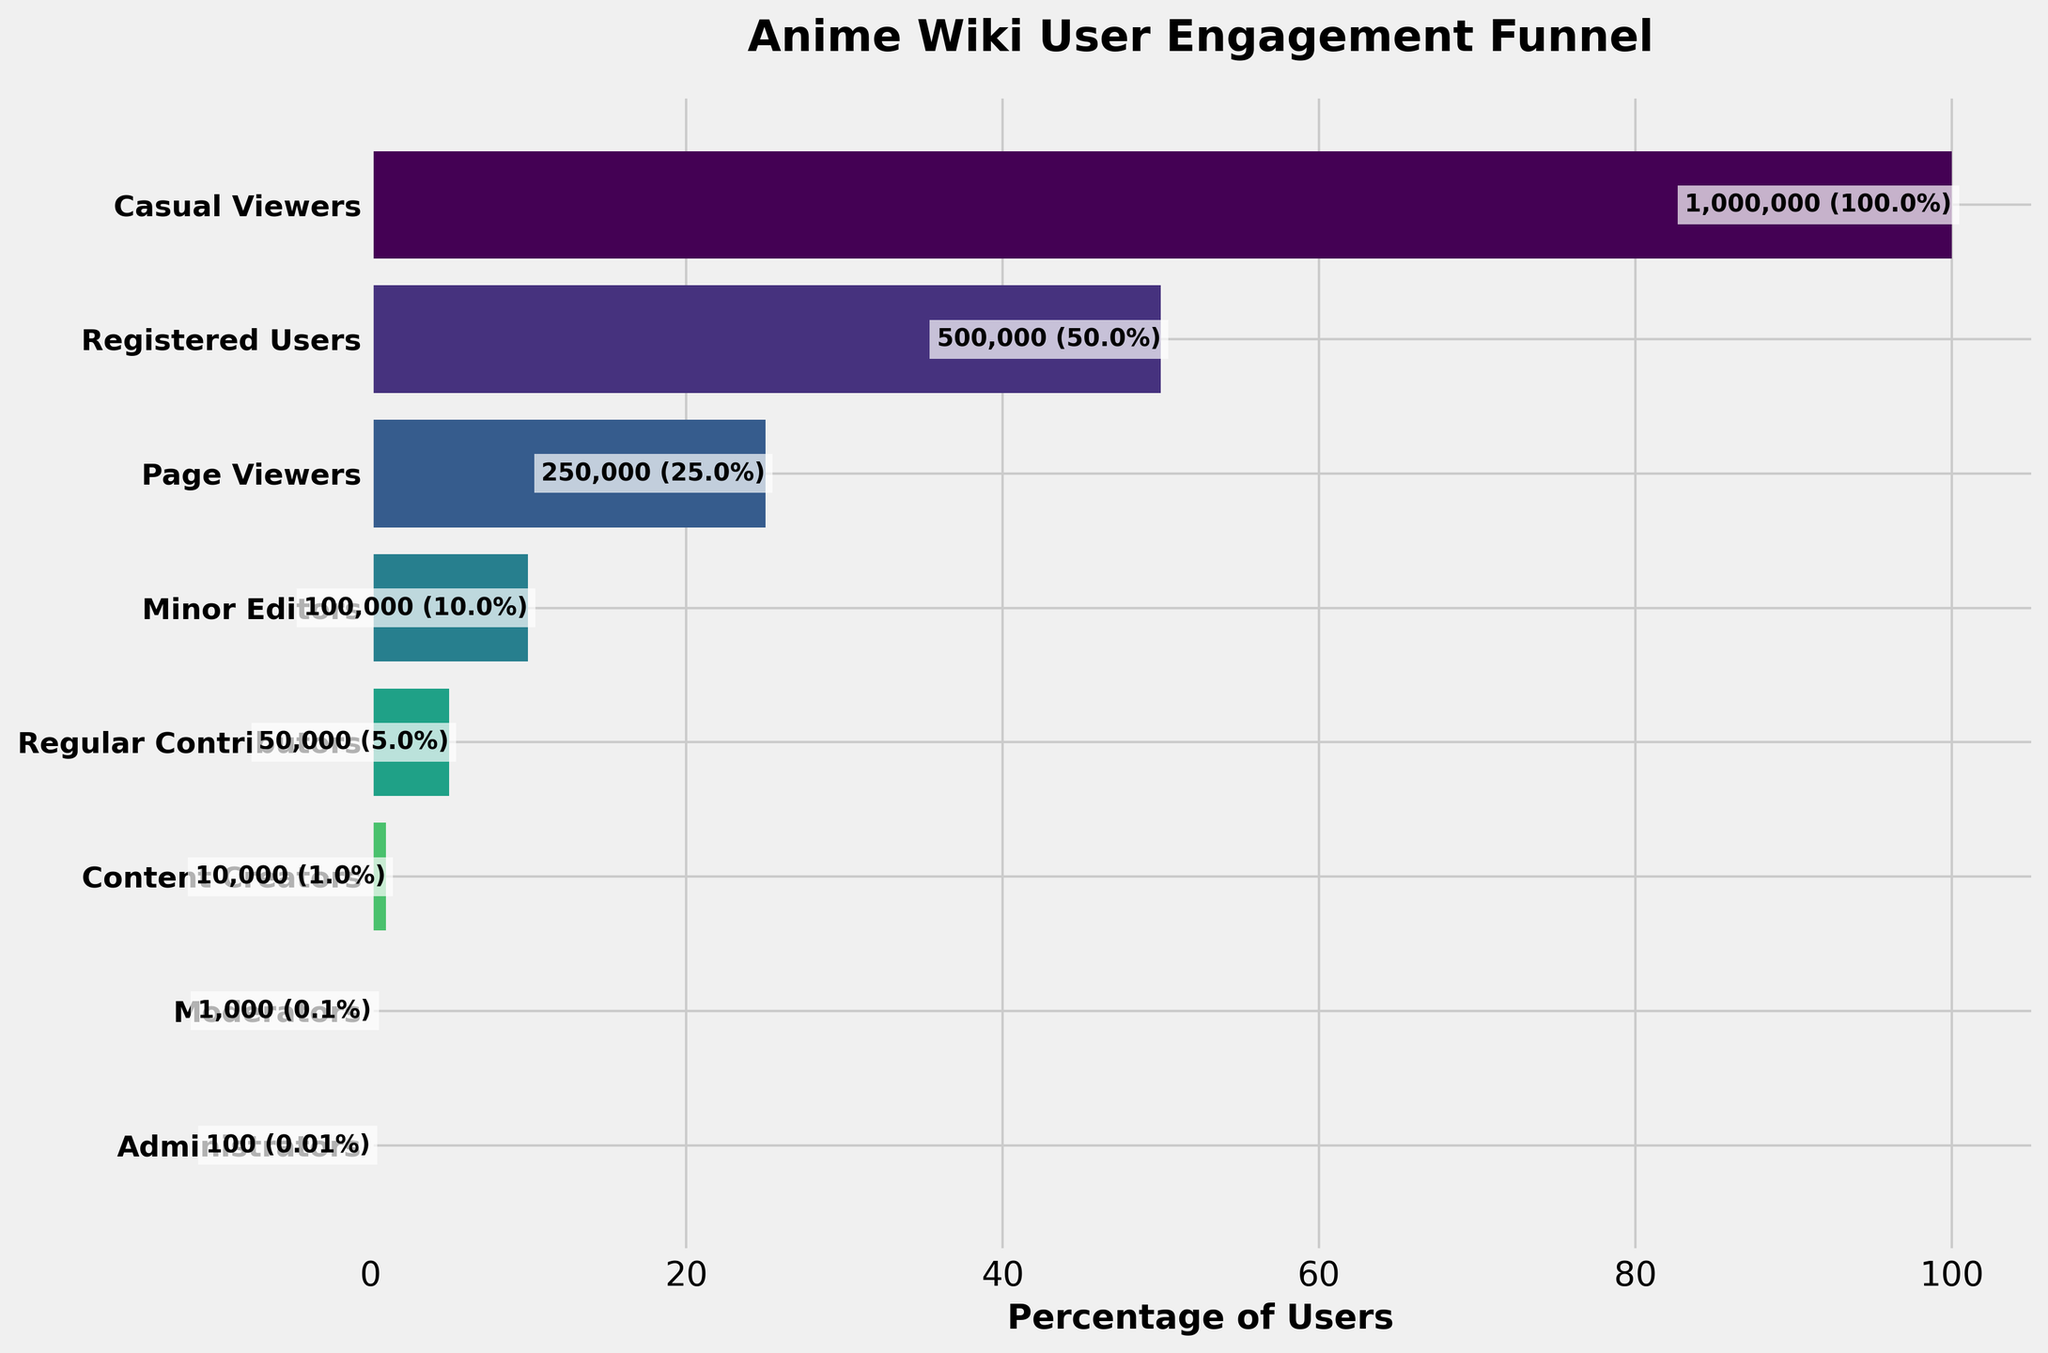What is the title of the figure? The title is located at the top of the funnel chart, it is clearly labeled to explain the main subject of the chart.
Answer: Anime Wiki User Engagement Funnel Which stage has the highest number of users? The longest bar in the funnel chart represents the stage with the highest number of users. It is the top-most level, which is "Casual Viewers".
Answer: Casual Viewers How many users are marked as "Moderators"? Look for the bar labeled "Moderators" and read the number of users next to it. The value provided is 1,000 users.
Answer: 1,000 Compare the number of "Minor Editors" to "Content Creators". Which group has more users and by how many? The bar for "Minor Editors" indicates 100,000 users and the bar for "Content Creators" indicates 10,000 users. By subtracting these, we find that Minor Editors have 90,000 more users.
Answer: Minor Editors have 90,000 more users What percentage of users are "Registered Users"? The percentage for each stage is displayed at the end of each bar. For "Registered Users", it shows 50%.
Answer: 50% What is the total number of users represented in the funnel chart? The total number of users can be directly inferred from the top-most bar labeled "Casual Viewers", which represents the initial total population of users. This value is 1,000,000 users.
Answer: 1,000,000 Which stage shows the greatest drop in user numbers compared to the previous stage? Compare the drop in user numbers between each consecutive stage. The largest drop is from "Regular Contributors" (50,000 users) to "Content Creators" (10,000 users), resulting in a decrease of 40,000 users.
Answer: From Regular Contributors to Content Creators What is the percentage difference between "Regular Contributors" and "Moderators"? The bar for "Regular Contributors" shows 5% and for "Moderators", it shows 0.1%. Subtracting these percentages gives a difference of 4.9%.
Answer: 4.9% How many stages does the user funnel have? Count the distinct labeled stages on the y-axis of the funnel chart. There are eight stages in total.
Answer: 8 Which stage has less than 50% of the total users but more than 10%? Check the percentages indicated next to each stage. The stage that meets this condition is "Page Viewers" with 25% of the users.
Answer: Page Viewers 